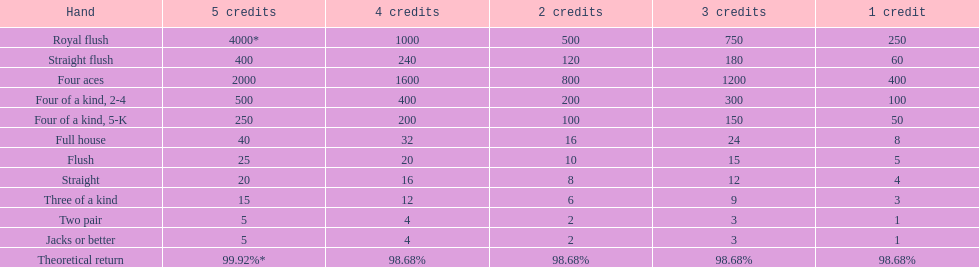What is the total amount of a 3 credit straight flush? 180. Could you parse the entire table? {'header': ['Hand', '5 credits', '4 credits', '2 credits', '3 credits', '1 credit'], 'rows': [['Royal flush', '4000*', '1000', '500', '750', '250'], ['Straight flush', '400', '240', '120', '180', '60'], ['Four aces', '2000', '1600', '800', '1200', '400'], ['Four of a kind, 2-4', '500', '400', '200', '300', '100'], ['Four of a kind, 5-K', '250', '200', '100', '150', '50'], ['Full house', '40', '32', '16', '24', '8'], ['Flush', '25', '20', '10', '15', '5'], ['Straight', '20', '16', '8', '12', '4'], ['Three of a kind', '15', '12', '6', '9', '3'], ['Two pair', '5', '4', '2', '3', '1'], ['Jacks or better', '5', '4', '2', '3', '1'], ['Theoretical return', '99.92%*', '98.68%', '98.68%', '98.68%', '98.68%']]} 